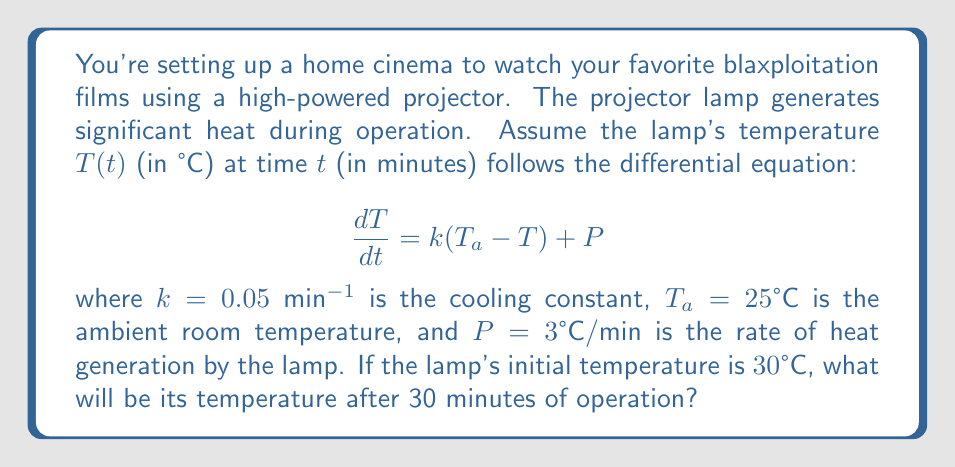Can you answer this question? To solve this problem, we need to use the given differential equation and initial condition:

1) The differential equation is: $\frac{dT}{dt} = k(T_a - T) + P$

2) Substituting the given values:
   $\frac{dT}{dt} = 0.05(25 - T) + 3$

3) This is a first-order linear differential equation. The general solution is:
   $T(t) = T_a + \frac{P}{k} + Ce^{-kt}$

   where $C$ is a constant determined by the initial condition.

4) Substituting the known values:
   $T(t) = 25 + \frac{3}{0.05} + Ce^{-0.05t} = 85 + Ce^{-0.05t}$

5) Using the initial condition $T(0) = 30°C$:
   $30 = 85 + C$
   $C = -55$

6) Therefore, the particular solution is:
   $T(t) = 85 - 55e^{-0.05t}$

7) To find the temperature after 30 minutes, we substitute $t = 30$:
   $T(30) = 85 - 55e^{-0.05(30)}$

8) Calculating:
   $T(30) = 85 - 55e^{-1.5} \approx 71.95°C$
Answer: The temperature of the projector lamp after 30 minutes of operation will be approximately $71.95°C$. 